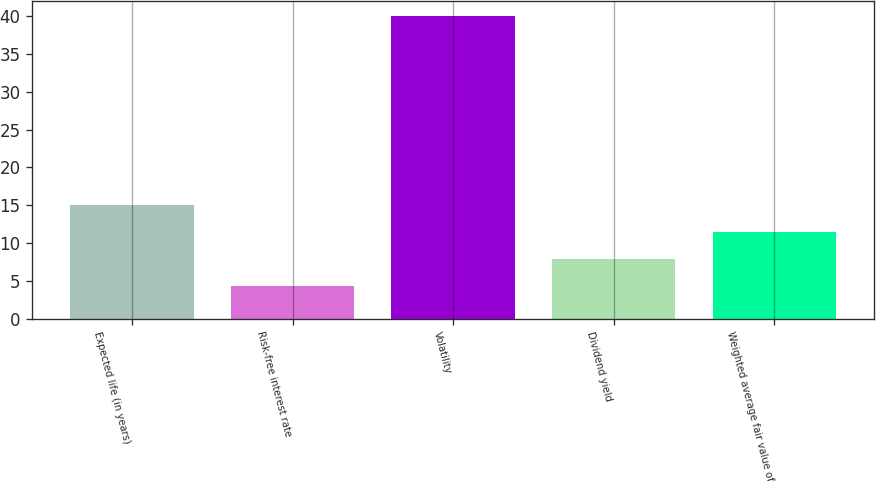Convert chart. <chart><loc_0><loc_0><loc_500><loc_500><bar_chart><fcel>Expected life (in years)<fcel>Risk-free interest rate<fcel>Volatility<fcel>Dividend yield<fcel>Weighted average fair value of<nl><fcel>15.05<fcel>4.37<fcel>40<fcel>7.93<fcel>11.49<nl></chart> 